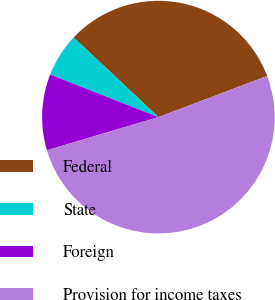<chart> <loc_0><loc_0><loc_500><loc_500><pie_chart><fcel>Federal<fcel>State<fcel>Foreign<fcel>Provision for income taxes<nl><fcel>32.24%<fcel>6.04%<fcel>10.56%<fcel>51.16%<nl></chart> 